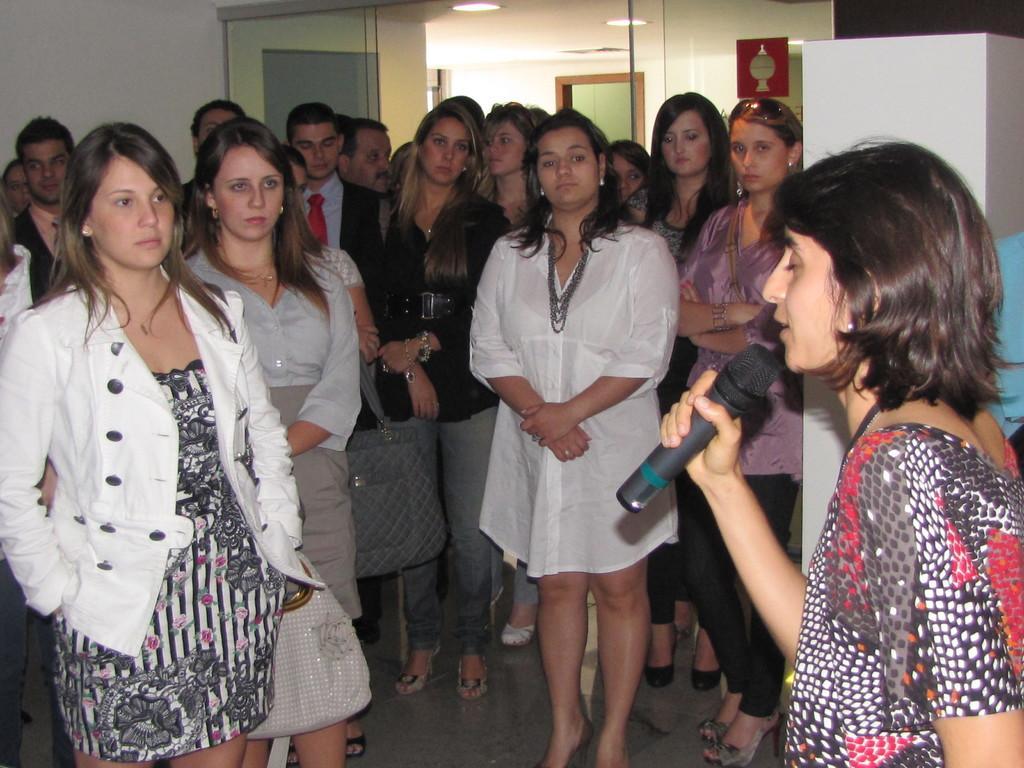Describe this image in one or two sentences. The image is taken inside a room. On the right side of the image there is a lady who is holding a mic is talking. To the left side there are people who are staring at her. In the background there is a door. 